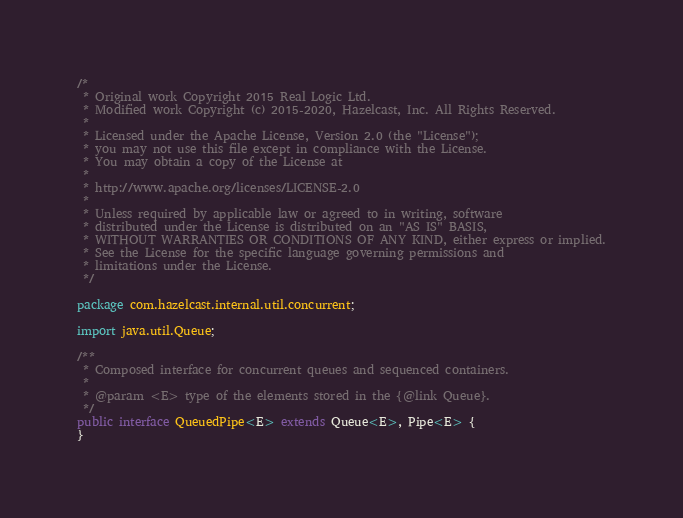<code> <loc_0><loc_0><loc_500><loc_500><_Java_>/*
 * Original work Copyright 2015 Real Logic Ltd.
 * Modified work Copyright (c) 2015-2020, Hazelcast, Inc. All Rights Reserved.
 *
 * Licensed under the Apache License, Version 2.0 (the "License");
 * you may not use this file except in compliance with the License.
 * You may obtain a copy of the License at
 *
 * http://www.apache.org/licenses/LICENSE-2.0
 *
 * Unless required by applicable law or agreed to in writing, software
 * distributed under the License is distributed on an "AS IS" BASIS,
 * WITHOUT WARRANTIES OR CONDITIONS OF ANY KIND, either express or implied.
 * See the License for the specific language governing permissions and
 * limitations under the License.
 */

package com.hazelcast.internal.util.concurrent;

import java.util.Queue;

/**
 * Composed interface for concurrent queues and sequenced containers.
 *
 * @param <E> type of the elements stored in the {@link Queue}.
 */
public interface QueuedPipe<E> extends Queue<E>, Pipe<E> {
}
</code> 